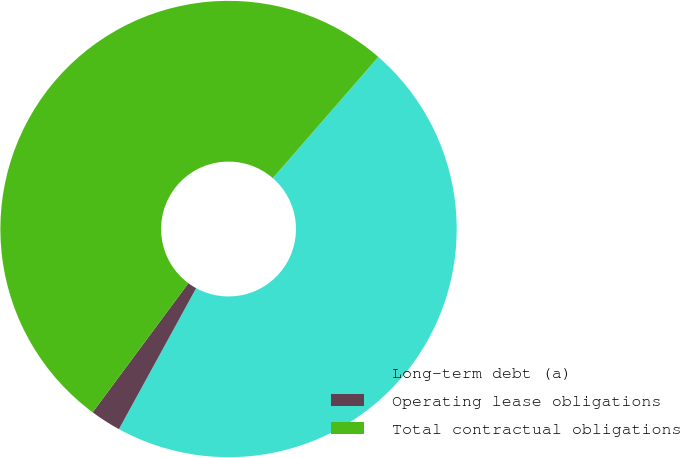Convert chart. <chart><loc_0><loc_0><loc_500><loc_500><pie_chart><fcel>Long-term debt (a)<fcel>Operating lease obligations<fcel>Total contractual obligations<nl><fcel>46.58%<fcel>2.18%<fcel>51.25%<nl></chart> 